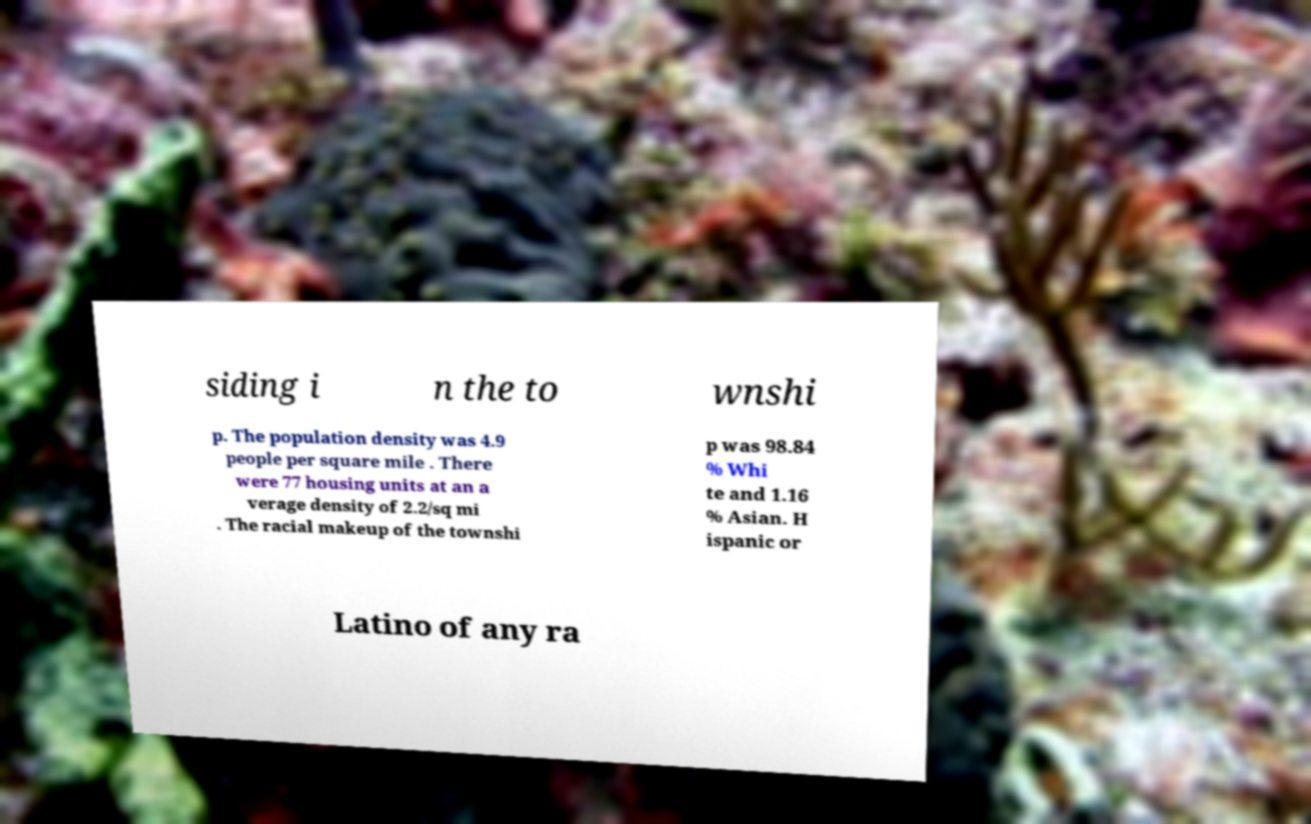Please read and relay the text visible in this image. What does it say? siding i n the to wnshi p. The population density was 4.9 people per square mile . There were 77 housing units at an a verage density of 2.2/sq mi . The racial makeup of the townshi p was 98.84 % Whi te and 1.16 % Asian. H ispanic or Latino of any ra 